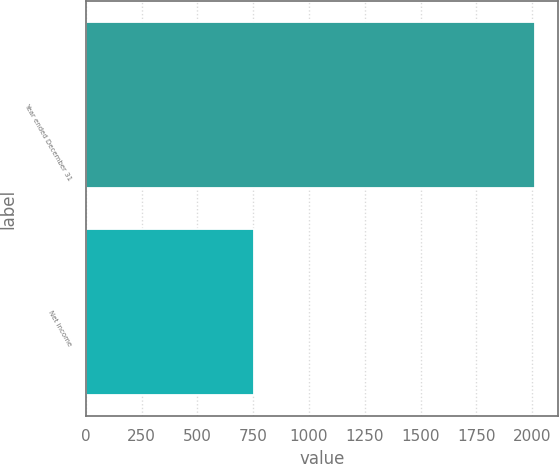Convert chart to OTSL. <chart><loc_0><loc_0><loc_500><loc_500><bar_chart><fcel>Year ended December 31<fcel>Net income<nl><fcel>2014<fcel>754<nl></chart> 